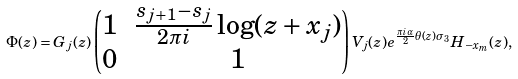<formula> <loc_0><loc_0><loc_500><loc_500>\Phi ( z ) = G _ { j } ( z ) \begin{pmatrix} 1 & \frac { s _ { j + 1 } - s _ { j } } { 2 \pi i } \log ( z + x _ { j } ) \\ 0 & 1 \end{pmatrix} V _ { j } ( z ) e ^ { \frac { \pi i \alpha } { 2 } \theta ( z ) \sigma _ { 3 } } H _ { - x _ { m } } ( z ) ,</formula> 